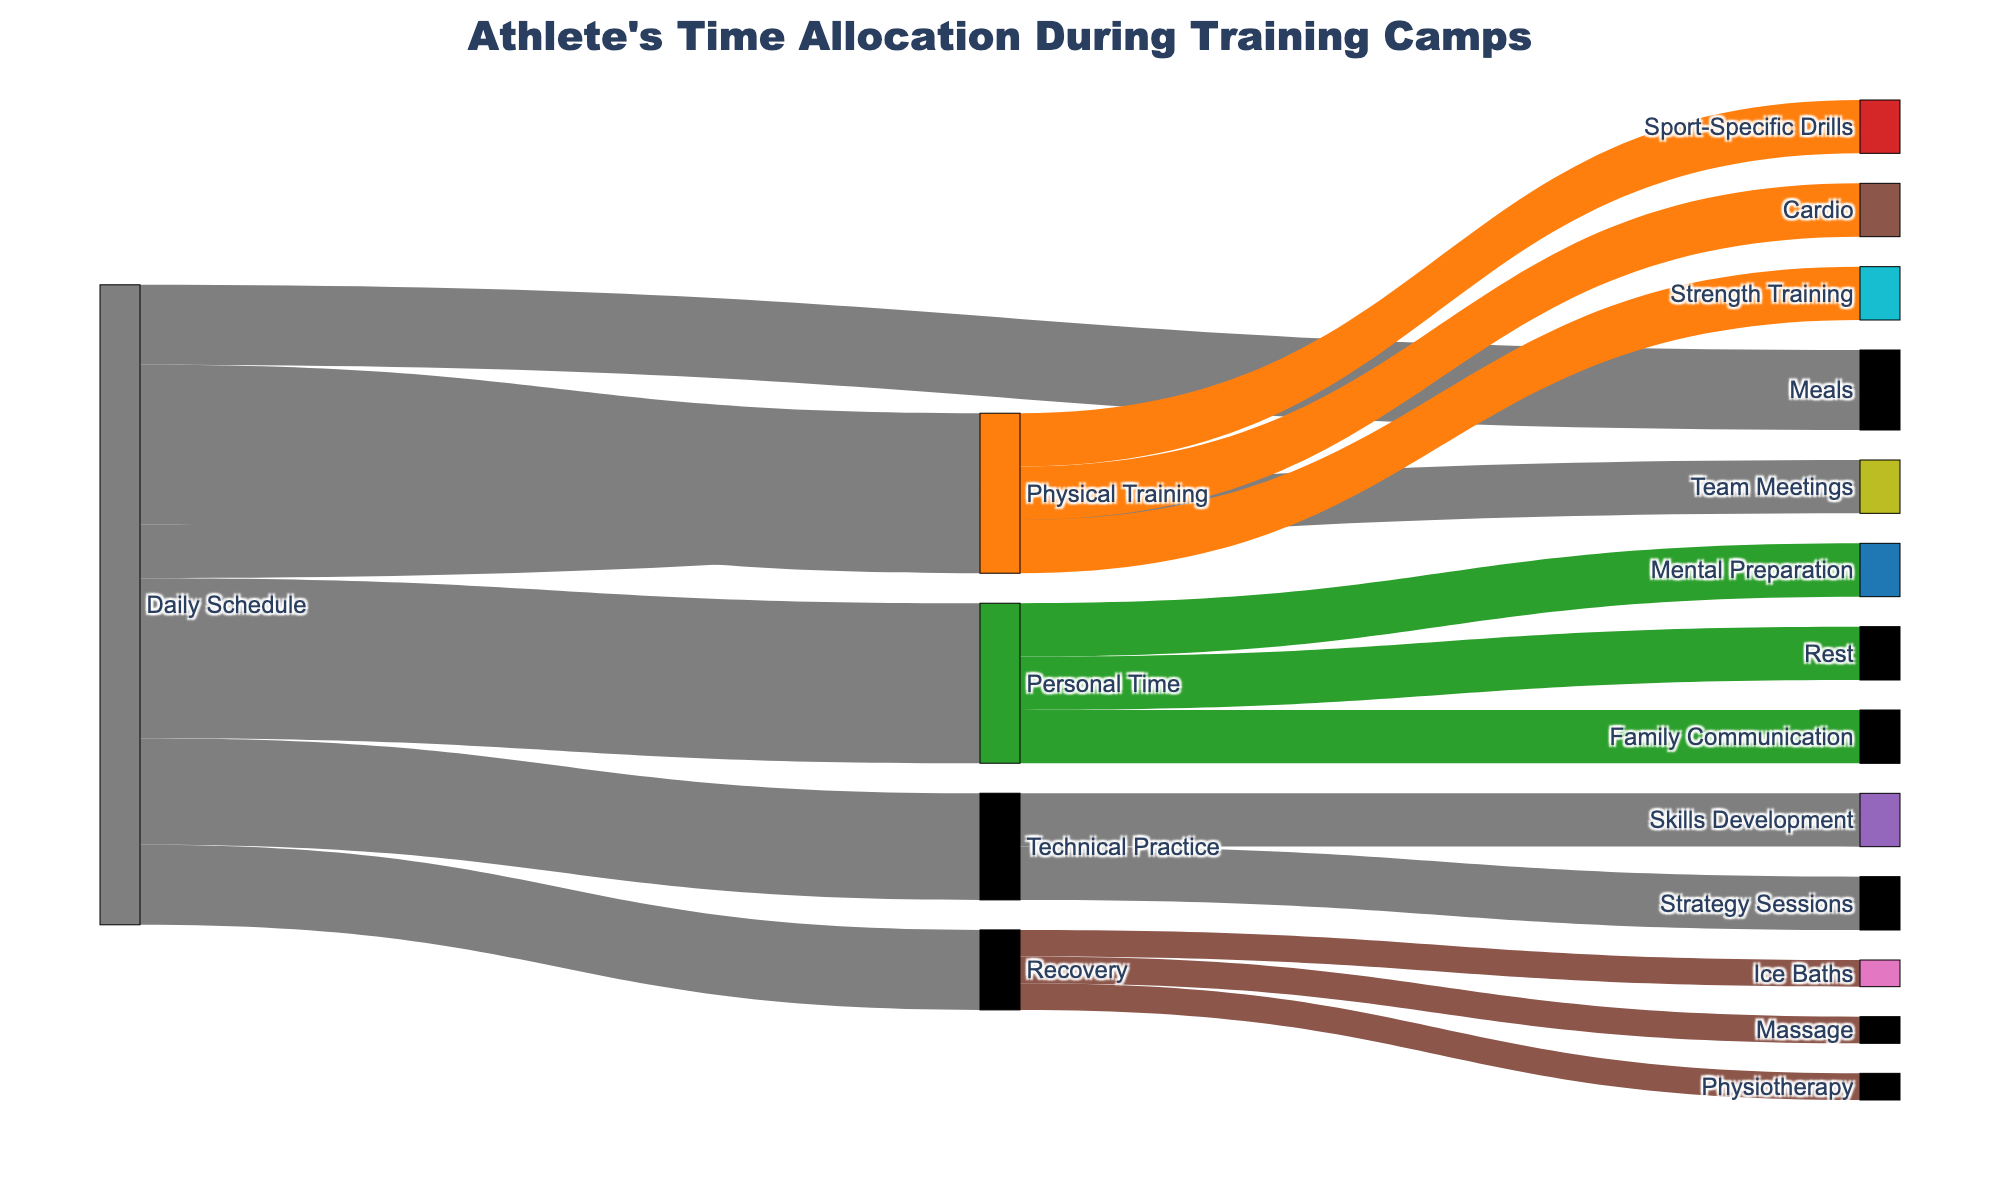What's the title of the figure? The title of the figure is displayed at the top and it reads "Athlete's Time Allocation During Training Camps".
Answer: Athlete's Time Allocation During Training Camps How many hours are allocated to Physical Training? From the diagram, the "Physical Training" node shows a value of 6 hours connecting from "Daily Schedule".
Answer: 6 hours Which activity within Personal Time takes up the most time? Within the "Personal Time" segment, all activities (Family Communication, Rest, and Mental Preparation) are allocated equally with 2 hours each.
Answer: All activities are equal How many hours are spent on Recovery activities in total? Adding the hours for Physio, Massage, and Ice Baths that connect from Recovery, we get 1+1+1 = 3 hours.
Answer: 3 hours What activity is allocated the least amount of time overall? The "Team Meetings" node from "Daily Schedule" shows a value of 2 hours, which is the smallest allocation in the diagram.
Answer: Team Meetings What's the difference in hours between Physical Training and Technical Practice? Physical Training is allocated 6 hours and Technical Practice 4 hours, so the difference is 6 - 4 = 2 hours.
Answer: 2 hours Which activity under Physical Training has the same time allocation as Ice Baths? The "Sport-Specific Drills" under Physical Training has the same allocation of 2 hours of Ice Baths under Recovery.
Answer: Sport-Specific Drills What are the three sub-activities of Technical Practice and how much time is spent on each? The sub-activities are Skills Development and Strategy Sessions, each allocated 2 hours under Technical Practice.
Answer: Skills Development and Strategy Sessions, 2 hours each Compare the total hours spent on meals and team meetings—are they equal, and if not, by how much do they differ? Meals are allocated 3 hours and Team Meetings 2 hours; they differ by 3 - 2 = 1 hour.
Answer: Differ by 1 hour How does the time spent on Team Meetings compare to the time spent on Mental Preparation? Both Team Meetings and Mental Preparation are allocated 2 hours each, so they are equal.
Answer: They are equal 